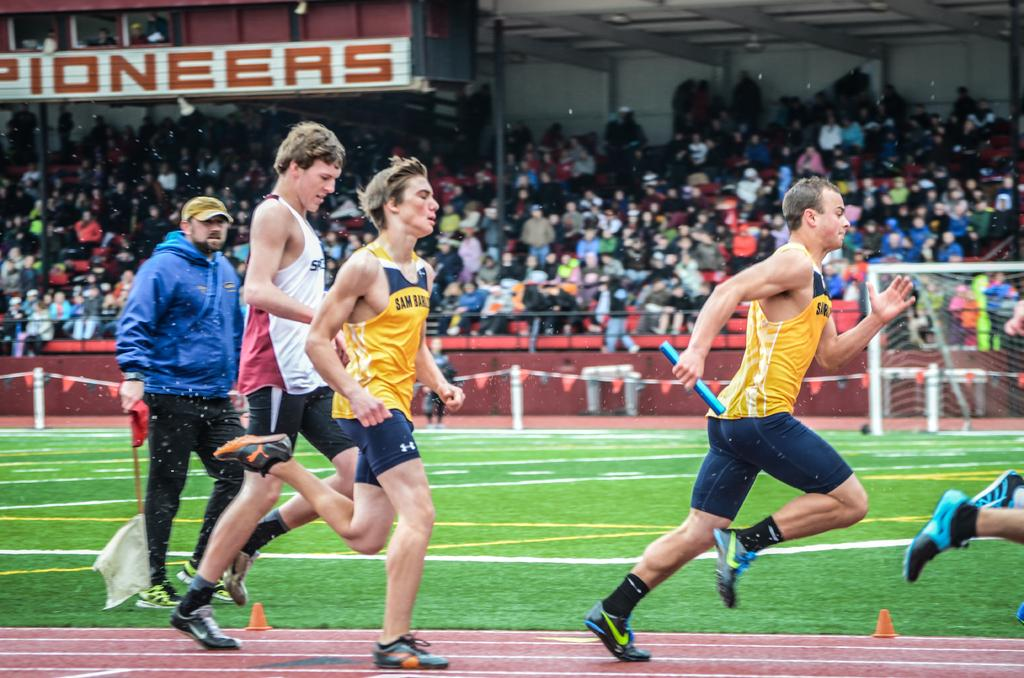What are the people in the image doing? There are people running in the image. Where are the running people located? The running people are on a ground. What are the sitting people doing in the image? The sitting people are watching the running people. Can you tell me how many goldfish are swimming in the image? There are no goldfish present in the image; it features people running and sitting. What type of test is being conducted in the image? There is no test being conducted in the image; it shows people running and sitting. 